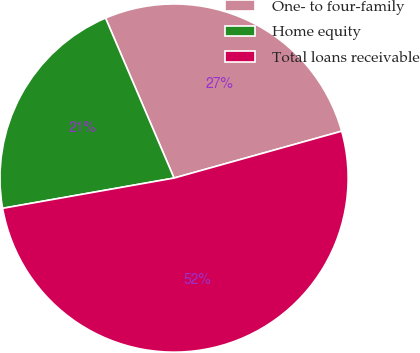Convert chart to OTSL. <chart><loc_0><loc_0><loc_500><loc_500><pie_chart><fcel>One- to four-family<fcel>Home equity<fcel>Total loans receivable<nl><fcel>27.1%<fcel>21.34%<fcel>51.56%<nl></chart> 